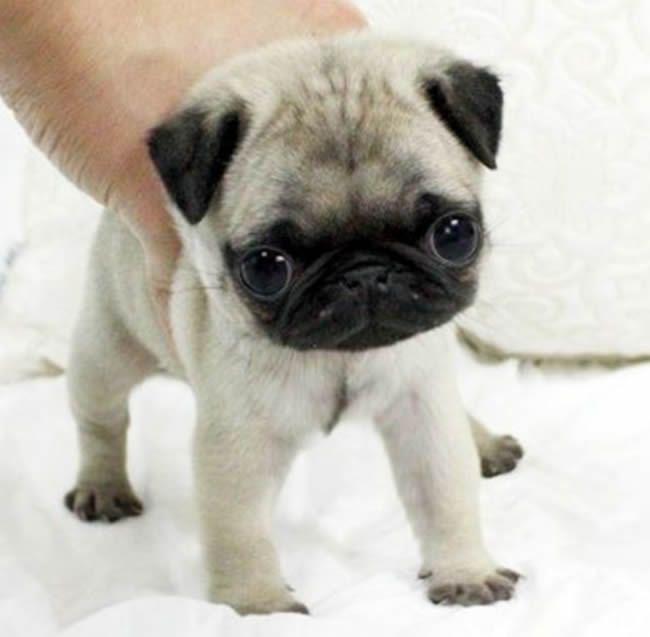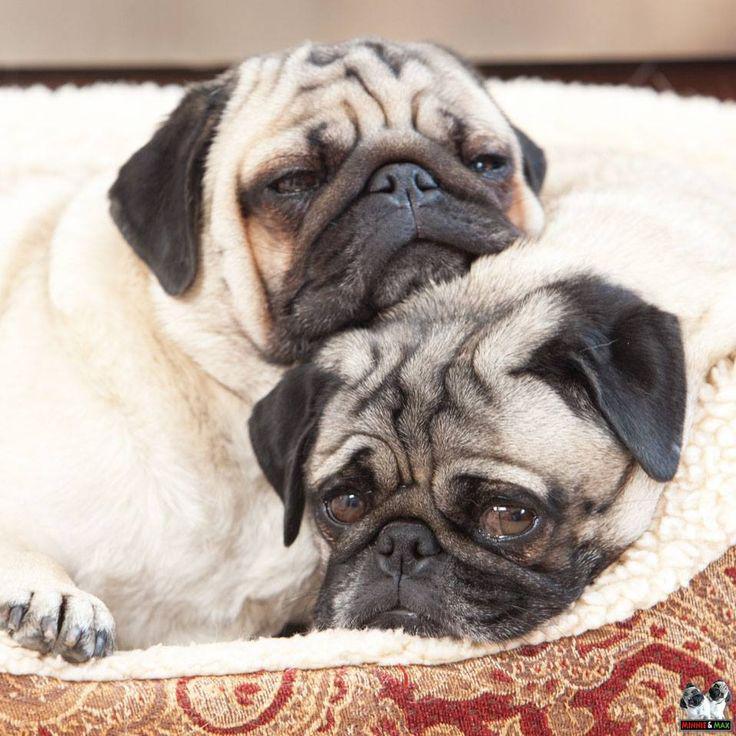The first image is the image on the left, the second image is the image on the right. For the images shown, is this caption "There are three or fewer dogs in total." true? Answer yes or no. Yes. The first image is the image on the left, the second image is the image on the right. Assess this claim about the two images: "The right image contains at least two dogs.". Correct or not? Answer yes or no. Yes. 